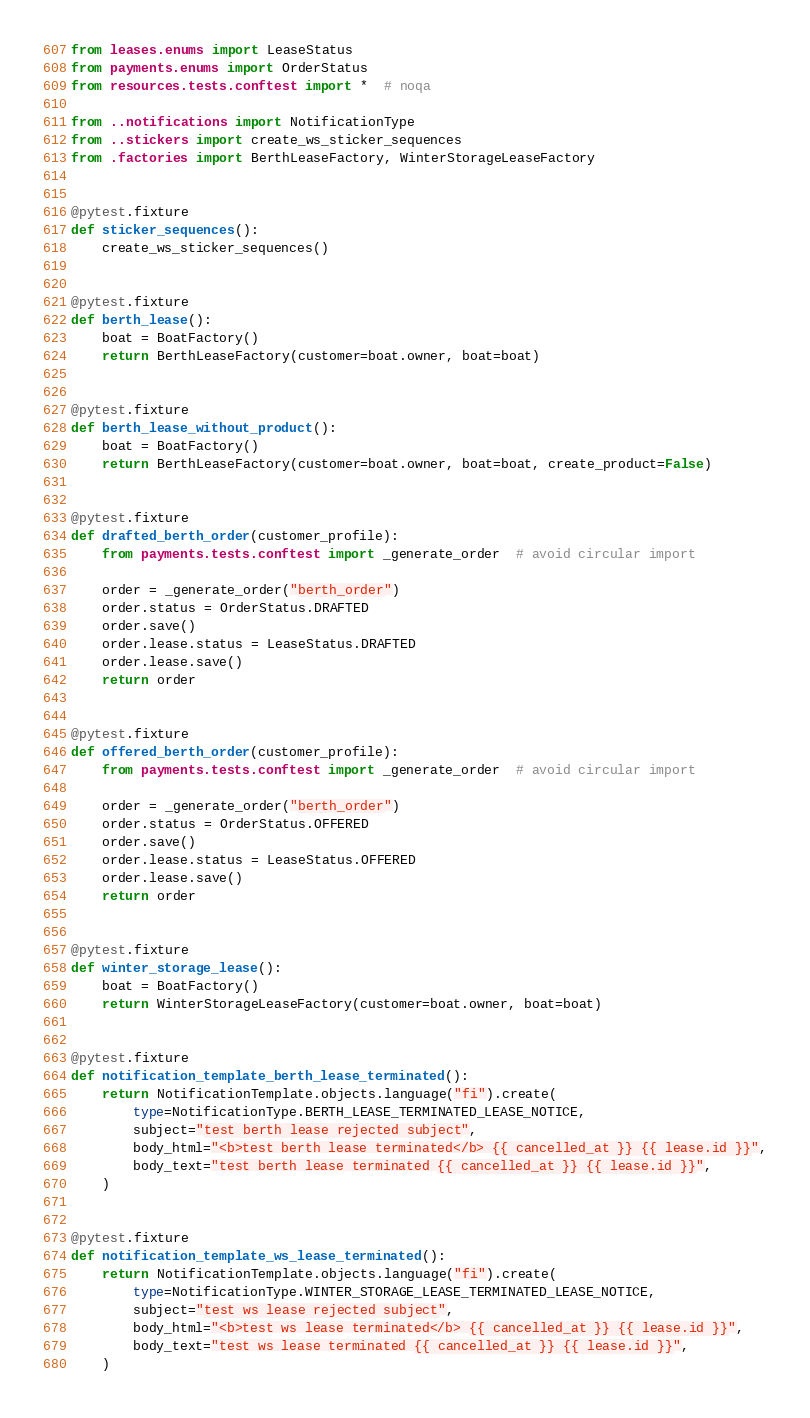<code> <loc_0><loc_0><loc_500><loc_500><_Python_>from leases.enums import LeaseStatus
from payments.enums import OrderStatus
from resources.tests.conftest import *  # noqa

from ..notifications import NotificationType
from ..stickers import create_ws_sticker_sequences
from .factories import BerthLeaseFactory, WinterStorageLeaseFactory


@pytest.fixture
def sticker_sequences():
    create_ws_sticker_sequences()


@pytest.fixture
def berth_lease():
    boat = BoatFactory()
    return BerthLeaseFactory(customer=boat.owner, boat=boat)


@pytest.fixture
def berth_lease_without_product():
    boat = BoatFactory()
    return BerthLeaseFactory(customer=boat.owner, boat=boat, create_product=False)


@pytest.fixture
def drafted_berth_order(customer_profile):
    from payments.tests.conftest import _generate_order  # avoid circular import

    order = _generate_order("berth_order")
    order.status = OrderStatus.DRAFTED
    order.save()
    order.lease.status = LeaseStatus.DRAFTED
    order.lease.save()
    return order


@pytest.fixture
def offered_berth_order(customer_profile):
    from payments.tests.conftest import _generate_order  # avoid circular import

    order = _generate_order("berth_order")
    order.status = OrderStatus.OFFERED
    order.save()
    order.lease.status = LeaseStatus.OFFERED
    order.lease.save()
    return order


@pytest.fixture
def winter_storage_lease():
    boat = BoatFactory()
    return WinterStorageLeaseFactory(customer=boat.owner, boat=boat)


@pytest.fixture
def notification_template_berth_lease_terminated():
    return NotificationTemplate.objects.language("fi").create(
        type=NotificationType.BERTH_LEASE_TERMINATED_LEASE_NOTICE,
        subject="test berth lease rejected subject",
        body_html="<b>test berth lease terminated</b> {{ cancelled_at }} {{ lease.id }}",
        body_text="test berth lease terminated {{ cancelled_at }} {{ lease.id }}",
    )


@pytest.fixture
def notification_template_ws_lease_terminated():
    return NotificationTemplate.objects.language("fi").create(
        type=NotificationType.WINTER_STORAGE_LEASE_TERMINATED_LEASE_NOTICE,
        subject="test ws lease rejected subject",
        body_html="<b>test ws lease terminated</b> {{ cancelled_at }} {{ lease.id }}",
        body_text="test ws lease terminated {{ cancelled_at }} {{ lease.id }}",
    )
</code> 